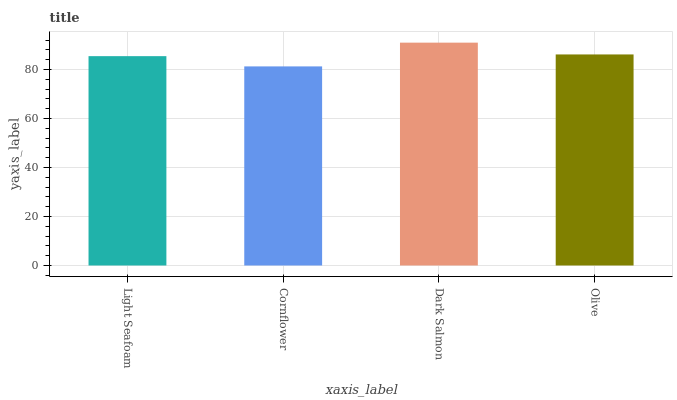Is Cornflower the minimum?
Answer yes or no. Yes. Is Dark Salmon the maximum?
Answer yes or no. Yes. Is Dark Salmon the minimum?
Answer yes or no. No. Is Cornflower the maximum?
Answer yes or no. No. Is Dark Salmon greater than Cornflower?
Answer yes or no. Yes. Is Cornflower less than Dark Salmon?
Answer yes or no. Yes. Is Cornflower greater than Dark Salmon?
Answer yes or no. No. Is Dark Salmon less than Cornflower?
Answer yes or no. No. Is Olive the high median?
Answer yes or no. Yes. Is Light Seafoam the low median?
Answer yes or no. Yes. Is Dark Salmon the high median?
Answer yes or no. No. Is Olive the low median?
Answer yes or no. No. 